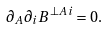<formula> <loc_0><loc_0><loc_500><loc_500>\partial _ { A } \partial _ { i } B ^ { \perp A i } = 0 .</formula> 